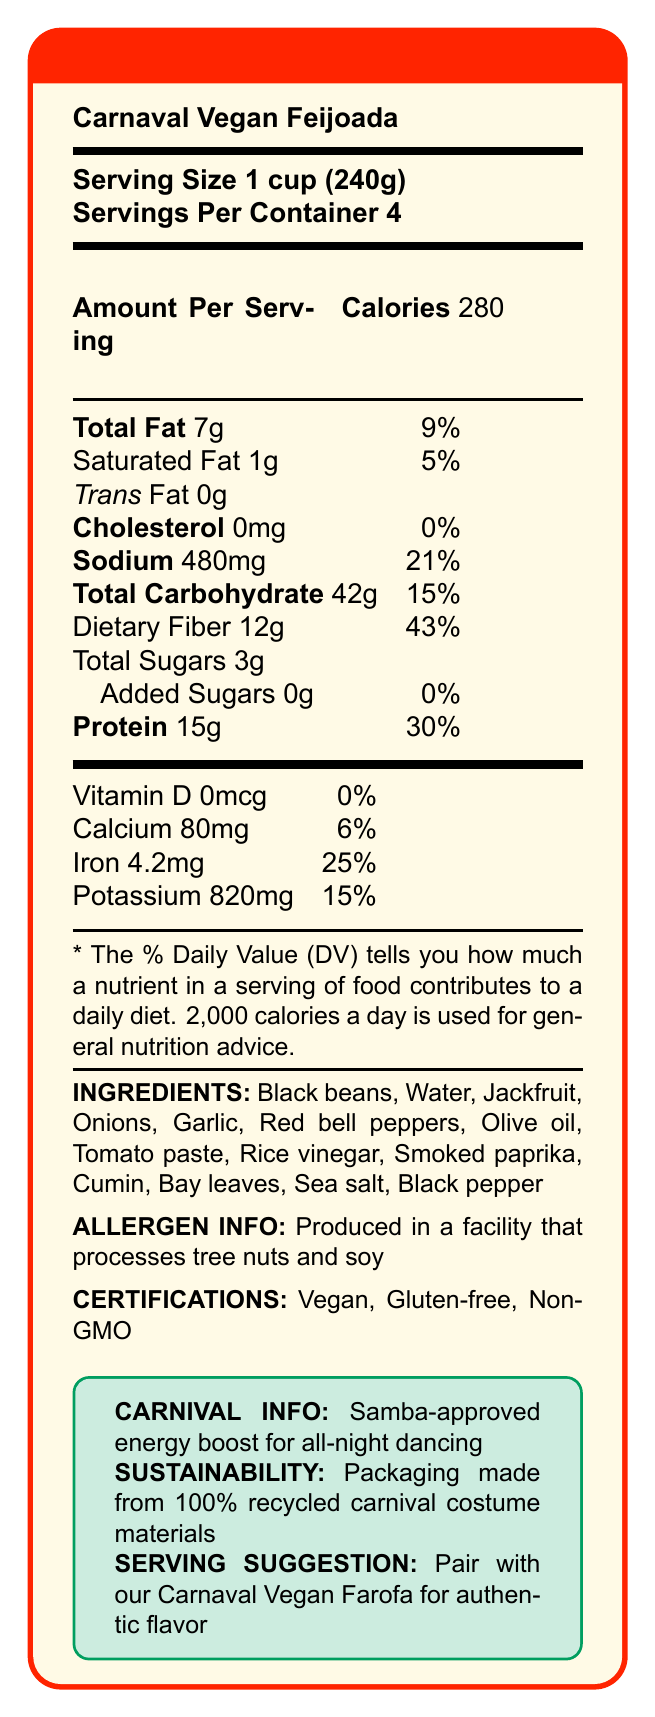what is the serving size for Carnaval Vegan Feijoada? The serving size is clearly listed as "1 cup (240g)" on the Nutrition Facts Label.
Answer: 1 cup (240g) how many servings are in one container? The number of servings per container is specified as 4.
Answer: 4 servings what is the total amount of dietary fiber per serving? The amount of dietary fiber per serving is stated as 12g.
Answer: 12g which certification does Carnaval Vegan Feijoada have? The certifications listed for this product are Vegan, Gluten-free, and Non-GMO.
Answer: Vegan, Gluten-free, Non-GMO where is this product produced? The document does not include any information about the specific location where the product is produced.
Answer: Cannot be determined how many calories are in one serving? Each serving contains 280 calories, as stated in the document.
Answer: 280 does the product contain any trans fat? The document specifies that it contains 0g of Trans Fat.
Answer: No is the product safe for someone allergic to tree nuts? The product is produced in a facility that processes tree nuts and soy, which poses a risk for someone with a tree nut allergy.
Answer: No how much iron does one serving provide towards daily value? One serving provides 25% of the daily value for iron.
Answer: 25% what does the sustainability section mention about the packaging? The document mentions that the packaging is made from 100% recycled carnival costume materials.
Answer: Packaging made from 100% recycled carnival costume materials how much protein is in one cup of Carnaval Vegan Feijoada? Each serving (1 cup) contains 15g of protein.
Answer: 15g what amount of sodium is in one serving and its percentage of daily value? One serving contains 480mg of sodium, which is 21% of the daily value.
Answer: 480mg, 21% which of the following ingredients are not part of Carnaval Vegan Feijoada? A. Jackfruit B. Olive oil C. Lentils D. Bay leaves Jackfruit, Olive oil, and Bay leaves are listed ingredients, while Lentils are not.
Answer: C. Lentils what is the purpose of the Carnaval Vegan Feijoada according to the carnival info section? A. Boost energy for all-night dancing B. Help with muscle recovery C. Enhance mental focus D. Reduce stress The carnival info section states it is "Samba-approved energy boost for all-night dancing."
Answer: A. Boost energy for all-night dancing which nutrient has the highest daily value percentage in one serving? The dietary fiber has the highest daily value percentage at 43%.
Answer: Dietary Fiber how is the taste suggested to be amplified for an authentic flavor? The serving suggestion mentions pairing it with Carnaval Vegan Farofa for authentic flavor.
Answer: Pair with our Carnaval Vegan Farofa summarize the main highlights of the document. The document is a detailed Nutrition Facts label that provides insight into the nutritional content, ingredients, certifications, and various attributes of Carnaval Vegan Feijoada, designed specifically for carnival celebrations.
Answer: The document presents the Nutrition Facts label for Carnaval Vegan Feijoada, a vegan and gluten-free alternative to classic feijoada. It provides detailed nutritional information per serving (1 cup), highlighting 280 calories, 15g protein, 12g dietary fiber, and certifications including Vegan, Gluten-free, and Non-GMO. It mentions the product's suitability for carnival energy needs and sustainability efforts with recycled packaging. There is also an allergen notice for tree nuts and soy processing. 